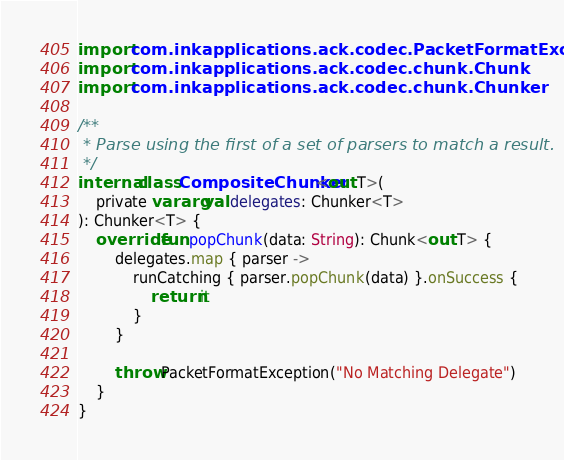Convert code to text. <code><loc_0><loc_0><loc_500><loc_500><_Kotlin_>import com.inkapplications.ack.codec.PacketFormatException
import com.inkapplications.ack.codec.chunk.Chunk
import com.inkapplications.ack.codec.chunk.Chunker

/**
 * Parse using the first of a set of parsers to match a result.
 */
internal class CompositeChunker<out T>(
    private vararg val delegates: Chunker<T>
): Chunker<T> {
    override fun popChunk(data: String): Chunk<out T> {
        delegates.map { parser ->
            runCatching { parser.popChunk(data) }.onSuccess {
                return it
            }
        }

        throw PacketFormatException("No Matching Delegate")
    }
}
</code> 